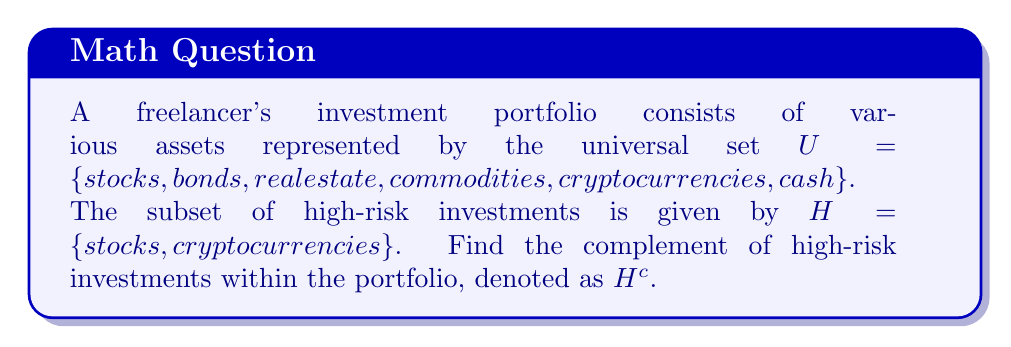Solve this math problem. To find the complement of high-risk investments within the portfolio, we need to identify all elements in the universal set $U$ that are not in the set of high-risk investments $H$. 

Let's follow these steps:

1. Identify the universal set $U$:
   $U = \{stocks, bonds, real estate, commodities, cryptocurrencies, cash\}$

2. Identify the set of high-risk investments $H$:
   $H = \{stocks, cryptocurrencies\}$

3. The complement of $H$, denoted as $H^c$, consists of all elements in $U$ that are not in $H$. We can express this mathematically as:
   $H^c = U \setminus H$

4. To find $H^c$, we remove the elements of $H$ from $U$:
   $H^c = \{bonds, real estate, commodities, cash\}$

These elements represent the lower-risk or more stable investments in the portfolio, which could be considered as the complement of high-risk investments.
Answer: $H^c = \{bonds, real estate, commodities, cash\}$ 